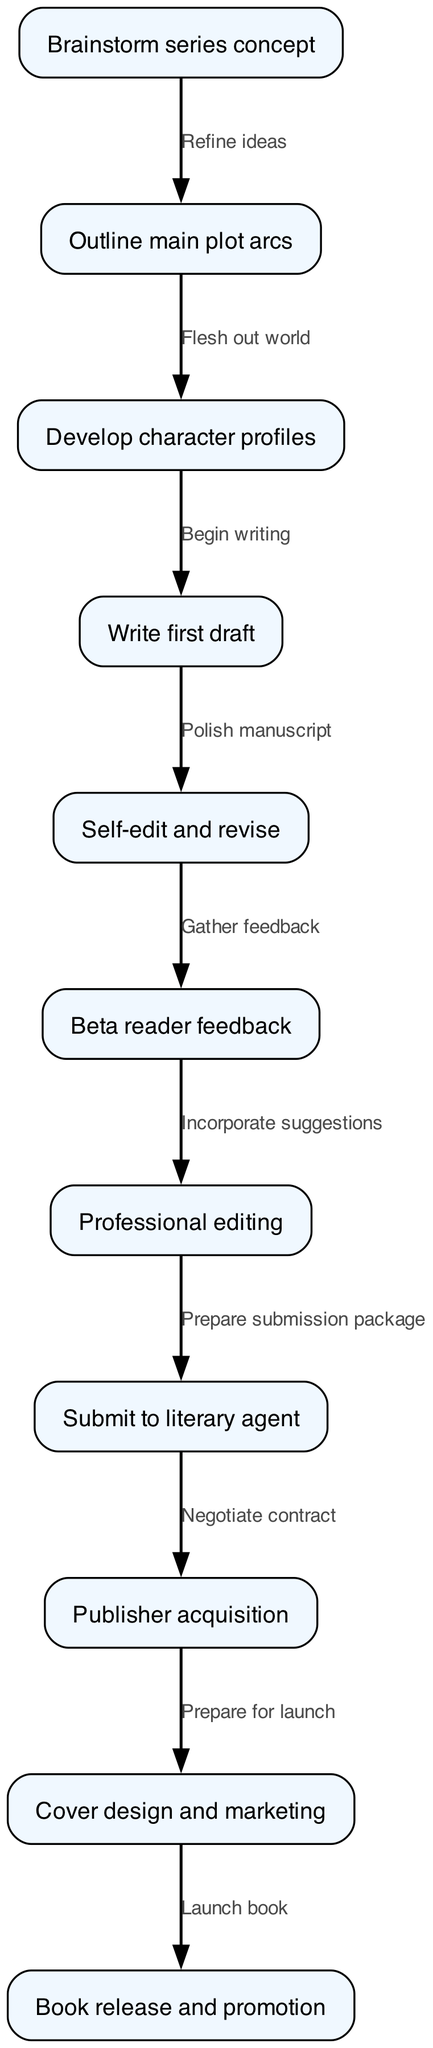What is the first step in the workflow? The first step in the workflow is "Brainstorm series concept," which is the initial node in the diagram.
Answer: Brainstorm series concept How many nodes are there in this diagram? By counting each distinct step or action in the workflow, we find there are 11 nodes in total, representing various stages from concept creation to book release.
Answer: 11 What is the last step of the workflow? The last step is "Book release and promotion," which is the final node in the sequence indicating the completion of the publishing process.
Answer: Book release and promotion Which two steps are directly connected by an edge labeled "Flesh out world"? The steps "Outline main plot arcs" and "Develop character profiles" are the two nodes that are directly connected by the edge labeled "Flesh out world."
Answer: Outline main plot arcs, Develop character profiles What comes immediately after "Self-edit and revise"? The step immediately following "Self-edit and revise" is "Beta reader feedback," indicating that feedback is sought once revisions are made.
Answer: Beta reader feedback How many edges are connecting the nodes? Counting each directed line between steps (edges), there are 10 edges showing the flow of actions within the workflow.
Answer: 10 What action follows after "Professional editing"? Following "Professional editing," the next action is "Submit to literary agent," marking an important transition in the publishing process.
Answer: Submit to literary agent Which step involves "Incorporate suggestions"? This action is part of the step "Professional editing," where feedback from beta readers is used to improve the manuscript.
Answer: Professional editing What is the relationship between "Write first draft" and "Self-edit and revise"? The relationship is that "Write first draft" leads directly to "Self-edit and revise," indicating that the editing process starts after completing the first draft.
Answer: Polishing the manuscript 